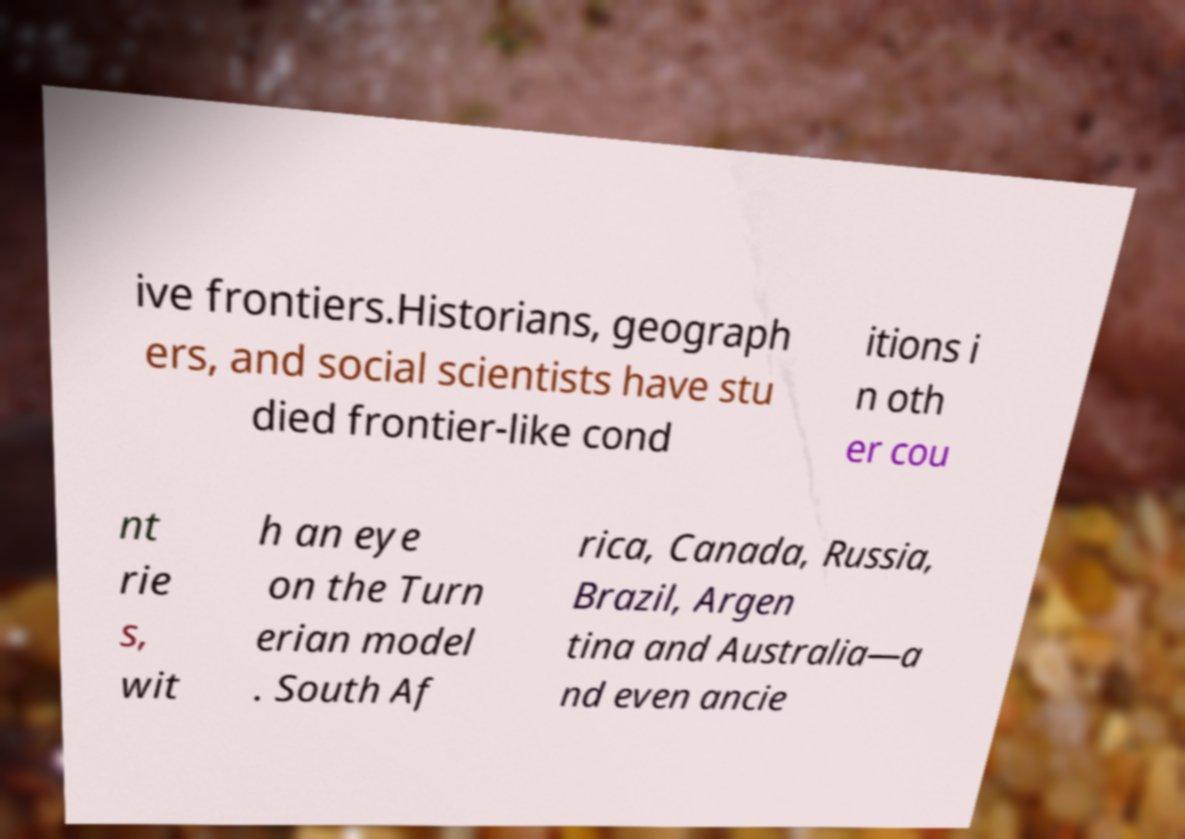Please identify and transcribe the text found in this image. ive frontiers.Historians, geograph ers, and social scientists have stu died frontier-like cond itions i n oth er cou nt rie s, wit h an eye on the Turn erian model . South Af rica, Canada, Russia, Brazil, Argen tina and Australia—a nd even ancie 